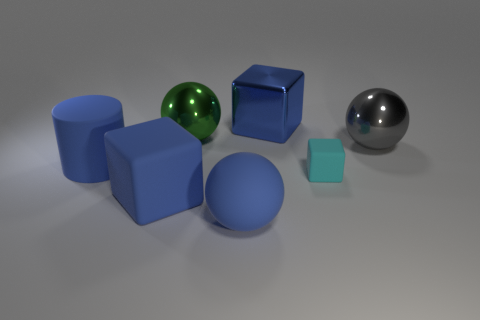There is a big metallic object right of the big block to the right of the green ball; what color is it?
Your answer should be very brief. Gray. Are the large blue ball and the blue cylinder made of the same material?
Ensure brevity in your answer.  Yes. Are there any green objects of the same shape as the blue metallic thing?
Provide a succinct answer. No. Is the color of the big rubber ball that is in front of the gray shiny object the same as the shiny block?
Your answer should be very brief. Yes. There is a metallic ball on the left side of the matte sphere; is it the same size as the matte block behind the large blue matte cube?
Provide a short and direct response. No. What size is the green thing that is made of the same material as the large gray ball?
Provide a succinct answer. Large. What number of cubes are in front of the gray thing and on the left side of the small matte object?
Give a very brief answer. 1. What number of things are either cyan matte blocks or large objects that are left of the green thing?
Give a very brief answer. 3. The metallic object that is the same color as the cylinder is what shape?
Offer a terse response. Cube. There is a object that is right of the small matte block; what is its color?
Ensure brevity in your answer.  Gray. 